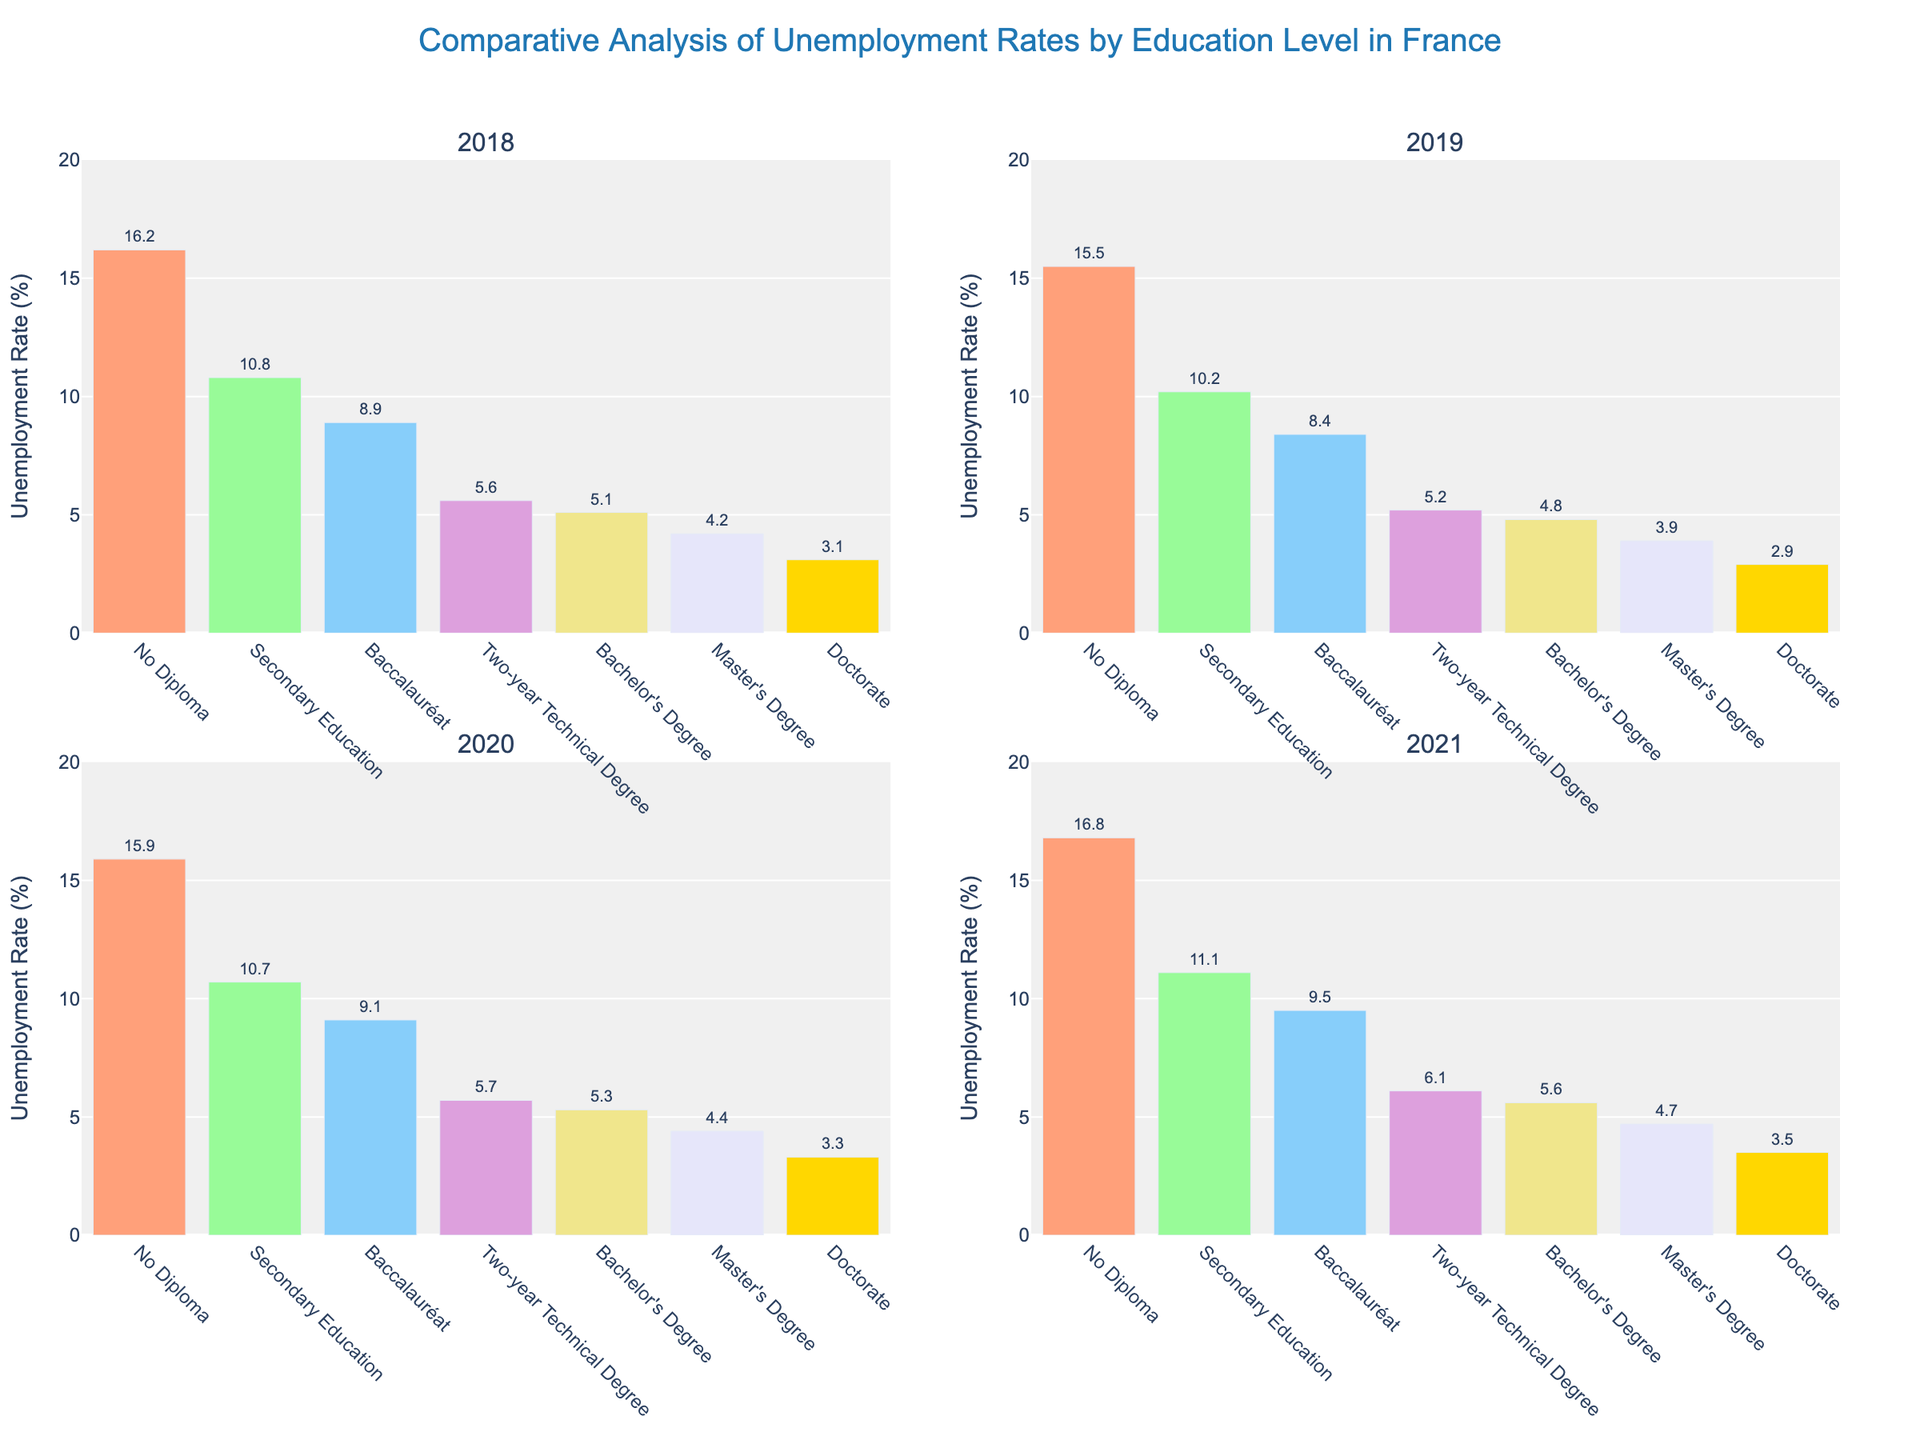What is the title of the figure? The title of the figure is usually placed at the top and is the most prominent text. It reads "Comparative Analysis of Unemployment Rates by Education Level in France".
Answer: Comparative Analysis of Unemployment Rates by Education Level in France What is the unemployment rate for 'No Diploma' in 2020? Look at the subplot titled 2020 and find the bar labeled 'No Diploma'. The value is indicated at the top of the bar as 15.9%.
Answer: 15.9% Which education level had the lowest unemployment rate in 2018? Find the smallest bar in the 2018 subplot. The shortest bar corresponds to the 'Doctorate' level, with a value of 3.1%.
Answer: Doctorate How did the unemployment rate for 'Master’s Degree' change from 2018 to 2021? Check the bars for 'Master’s Degree' in each year subplot. In 2018, it is 4.2%; in 2021, it is 4.7%. Calculate the difference: 4.7% - 4.2% = 0.5%.
Answer: Increased by 0.5% Which year showed the highest unemployment rate for 'Baccalauréat'? Find the tallest bar within the 'Baccalauréat' category across all subplots. The tallest bar is in 2021 with a value of 9.5%.
Answer: 2021 Compare the unemployment rates for 'Secondary Education' and 'Bachelor's Degree' in 2019. Which one is higher? Look at the 2019 subplot. The bar for 'Secondary Education' is 10.2%, while the bar for 'Bachelor's Degree' is 4.8%. Since 10.2% is greater than 4.8%, 'Secondary Education' has a higher unemployment rate.
Answer: Secondary Education How much did the unemployment rate for 'Two-year Technical Degree' change from 2018 to 2020? Look at the bars for 'Two-year Technical Degree' for 2018 and 2020. In 2018, it is 5.6%; in 2020, it is 5.7%. Calculate the difference: 5.7% - 5.6% = 0.1%.
Answer: Increased by 0.1% Which education level shows the most consistent unemployment rate over the four years? Look at the bars for each education level across all the subplots. 'Doctorate' has very little variability, with values of 3.1%, 2.9%, 3.3%, and 3.5%.
Answer: Doctorate What is the average unemployment rate for 'Bachelor's Degree' across all the years? Sum the unemployment rates for 'Bachelor's Degree' from 2018 to 2021 and divide by the number of years: (5.1 + 4.8 + 5.3 + 5.6) / 4 = 20.8 / 4 = 5.2%.
Answer: 5.2% In which year did 'No Diploma' have a significant increase in unemployment rate? Examine the bars for 'No Diploma' across all years and find the year with the largest increase. From 2019 to 2020, the rate increased from 15.5% to 15.9%, and from 2020 to 2021, it increased from 15.9% to 16.8%. The significant increase is between 2020 and 2021 (0.9%).
Answer: 2021 